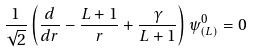<formula> <loc_0><loc_0><loc_500><loc_500>\frac { 1 } { \sqrt { 2 } } \left ( \frac { d } { d r } - \frac { L + 1 } { r } + \frac { \gamma } { L + 1 } \right ) \psi ^ { 0 } _ { ( L ) } = 0</formula> 